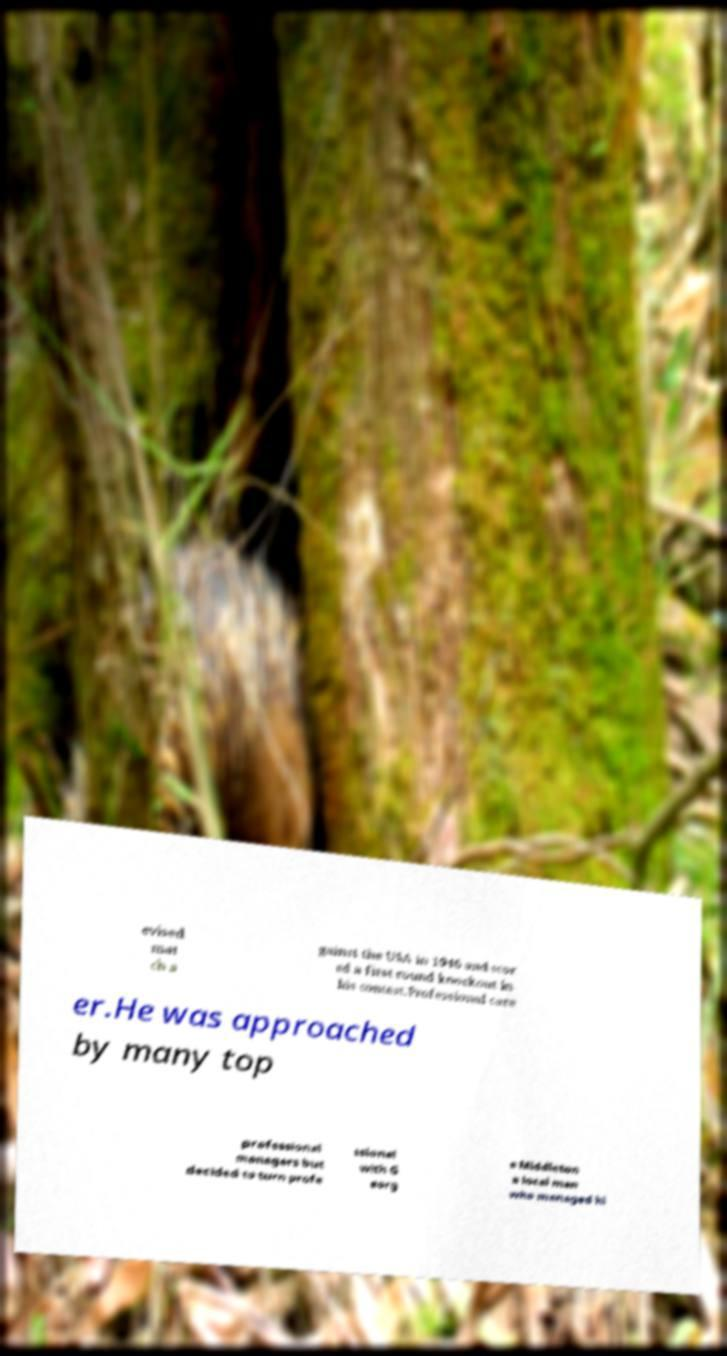For documentation purposes, I need the text within this image transcribed. Could you provide that? evised mat ch a gainst the USA in 1946 and scor ed a first round knockout in his contest.Professional care er.He was approached by many top professional managers but decided to turn profe ssional with G eorg e Middleton a local man who managed hi 